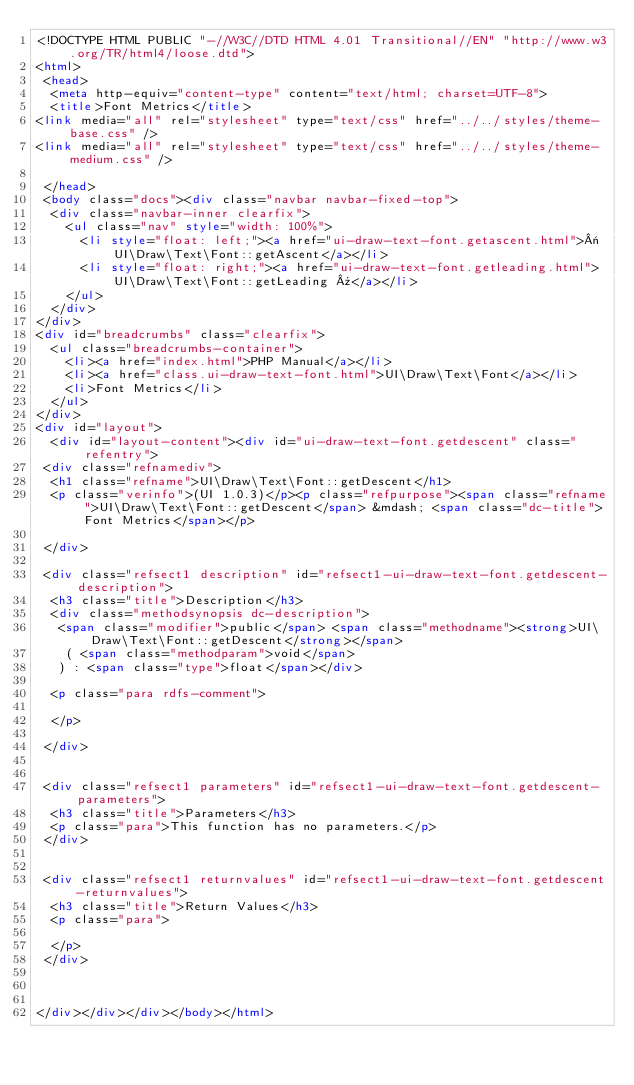<code> <loc_0><loc_0><loc_500><loc_500><_HTML_><!DOCTYPE HTML PUBLIC "-//W3C//DTD HTML 4.01 Transitional//EN" "http://www.w3.org/TR/html4/loose.dtd">
<html>
 <head>
  <meta http-equiv="content-type" content="text/html; charset=UTF-8">
  <title>Font Metrics</title>
<link media="all" rel="stylesheet" type="text/css" href="../../styles/theme-base.css" />
<link media="all" rel="stylesheet" type="text/css" href="../../styles/theme-medium.css" />

 </head>
 <body class="docs"><div class="navbar navbar-fixed-top">
  <div class="navbar-inner clearfix">
    <ul class="nav" style="width: 100%">
      <li style="float: left;"><a href="ui-draw-text-font.getascent.html">« UI\Draw\Text\Font::getAscent</a></li>
      <li style="float: right;"><a href="ui-draw-text-font.getleading.html">UI\Draw\Text\Font::getLeading »</a></li>
    </ul>
  </div>
</div>
<div id="breadcrumbs" class="clearfix">
  <ul class="breadcrumbs-container">
    <li><a href="index.html">PHP Manual</a></li>
    <li><a href="class.ui-draw-text-font.html">UI\Draw\Text\Font</a></li>
    <li>Font Metrics</li>
  </ul>
</div>
<div id="layout">
  <div id="layout-content"><div id="ui-draw-text-font.getdescent" class="refentry">
 <div class="refnamediv">
  <h1 class="refname">UI\Draw\Text\Font::getDescent</h1>
  <p class="verinfo">(UI 1.0.3)</p><p class="refpurpose"><span class="refname">UI\Draw\Text\Font::getDescent</span> &mdash; <span class="dc-title">Font Metrics</span></p>

 </div>

 <div class="refsect1 description" id="refsect1-ui-draw-text-font.getdescent-description">
  <h3 class="title">Description</h3>
  <div class="methodsynopsis dc-description">
   <span class="modifier">public</span> <span class="methodname"><strong>UI\Draw\Text\Font::getDescent</strong></span>
    ( <span class="methodparam">void</span>
   ) : <span class="type">float</span></div>

  <p class="para rdfs-comment">

  </p>

 </div>


 <div class="refsect1 parameters" id="refsect1-ui-draw-text-font.getdescent-parameters">
  <h3 class="title">Parameters</h3>
  <p class="para">This function has no parameters.</p>
 </div>


 <div class="refsect1 returnvalues" id="refsect1-ui-draw-text-font.getdescent-returnvalues">
  <h3 class="title">Return Values</h3>
  <p class="para">
   
  </p>
 </div>



</div></div></div></body></html></code> 